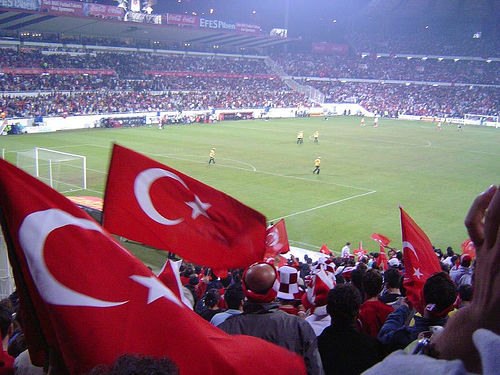<image>
Can you confirm if the man is to the left of the man? No. The man is not to the left of the man. From this viewpoint, they have a different horizontal relationship. Is the turk behind the hat? No. The turk is not behind the hat. From this viewpoint, the turk appears to be positioned elsewhere in the scene. Where is the man in relation to the man? Is it in front of the man? No. The man is not in front of the man. The spatial positioning shows a different relationship between these objects. 